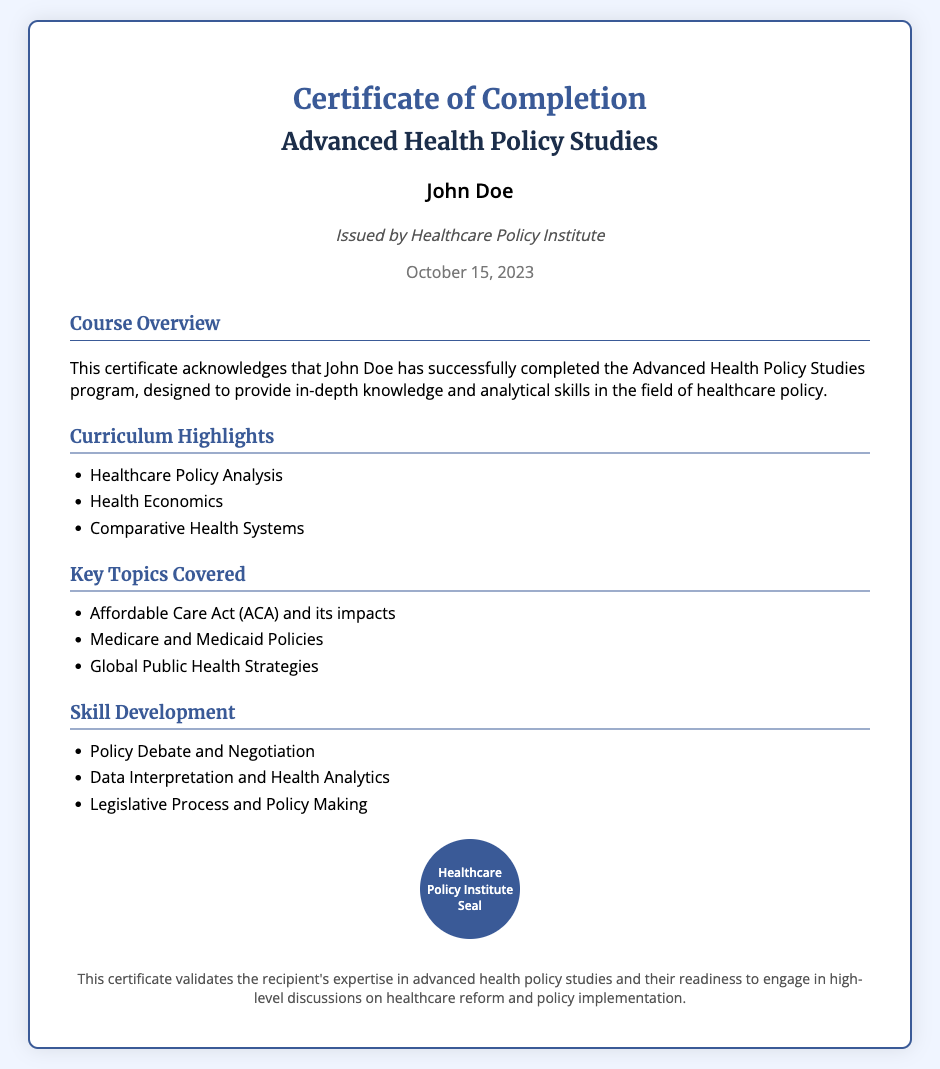What is the recipient's name? The recipient's name is stated at the top of the certificate.
Answer: John Doe Who issued the certificate? The issuer is mentioned just below the recipient's name.
Answer: Healthcare Policy Institute What is the date of issuance? The date is clearly displayed at the bottom of the issuer's information.
Answer: October 15, 2023 What is the title of the program completed? The program title is highlighted in the header section.
Answer: Advanced Health Policy Studies What is one curriculum highlight? Curriculum highlights are provided in a list format in the document.
Answer: Healthcare Policy Analysis Name one key topic covered in the course. Key topics covered are listed in a section dedicated to that information.
Answer: Affordable Care Act (ACA) and its impacts What is one skill developed through the program? Skills development is detailed in a specific section of the certificate.
Answer: Policy Debate and Negotiation What does the certificate validate? The footer provides a summary of what the certificate validates.
Answer: Expertise in advanced health policy studies 